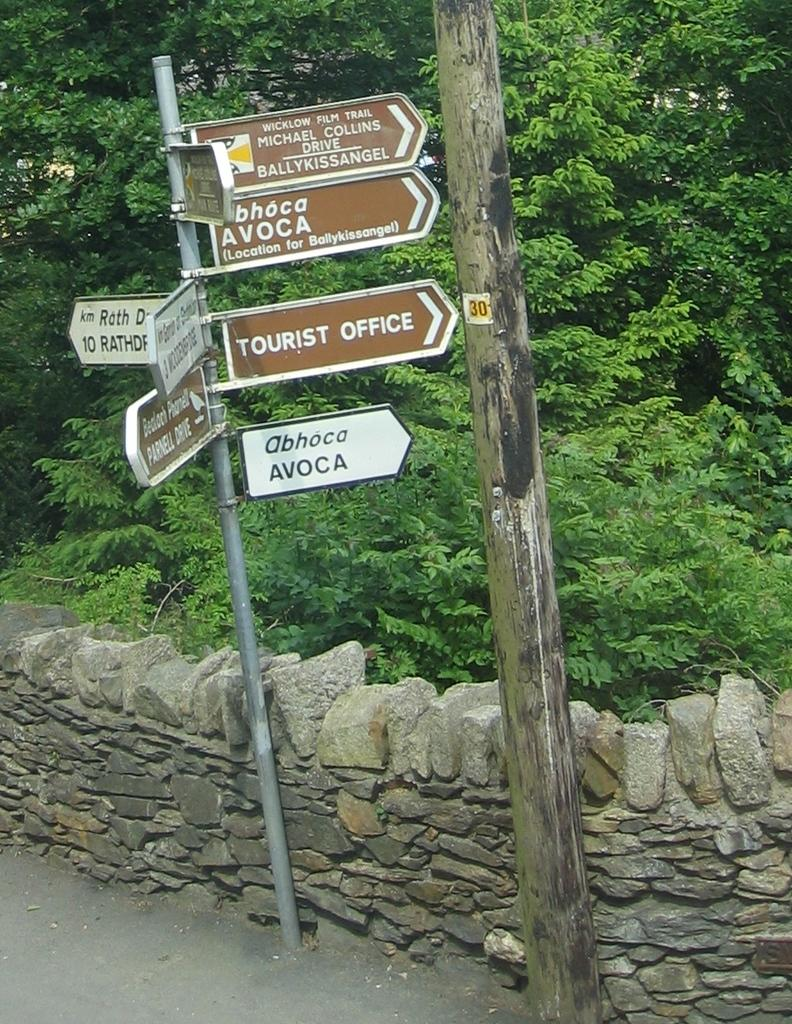What objects are located in the center of the image? There are boards and poles in the center of the image. What structures can be seen at the bottom of the image? There is a stone wall and a road at the bottom of the image. What type of vegetation is visible in the background? There are trees visible in the background. Can you see a deer walking on the road in the image? There is no deer visible in the image; only the stone wall, road, and trees are present. What type of ear is attached to the stone wall in the image? There is no ear present in the image; the stone wall is a solid structure without any appendages. 